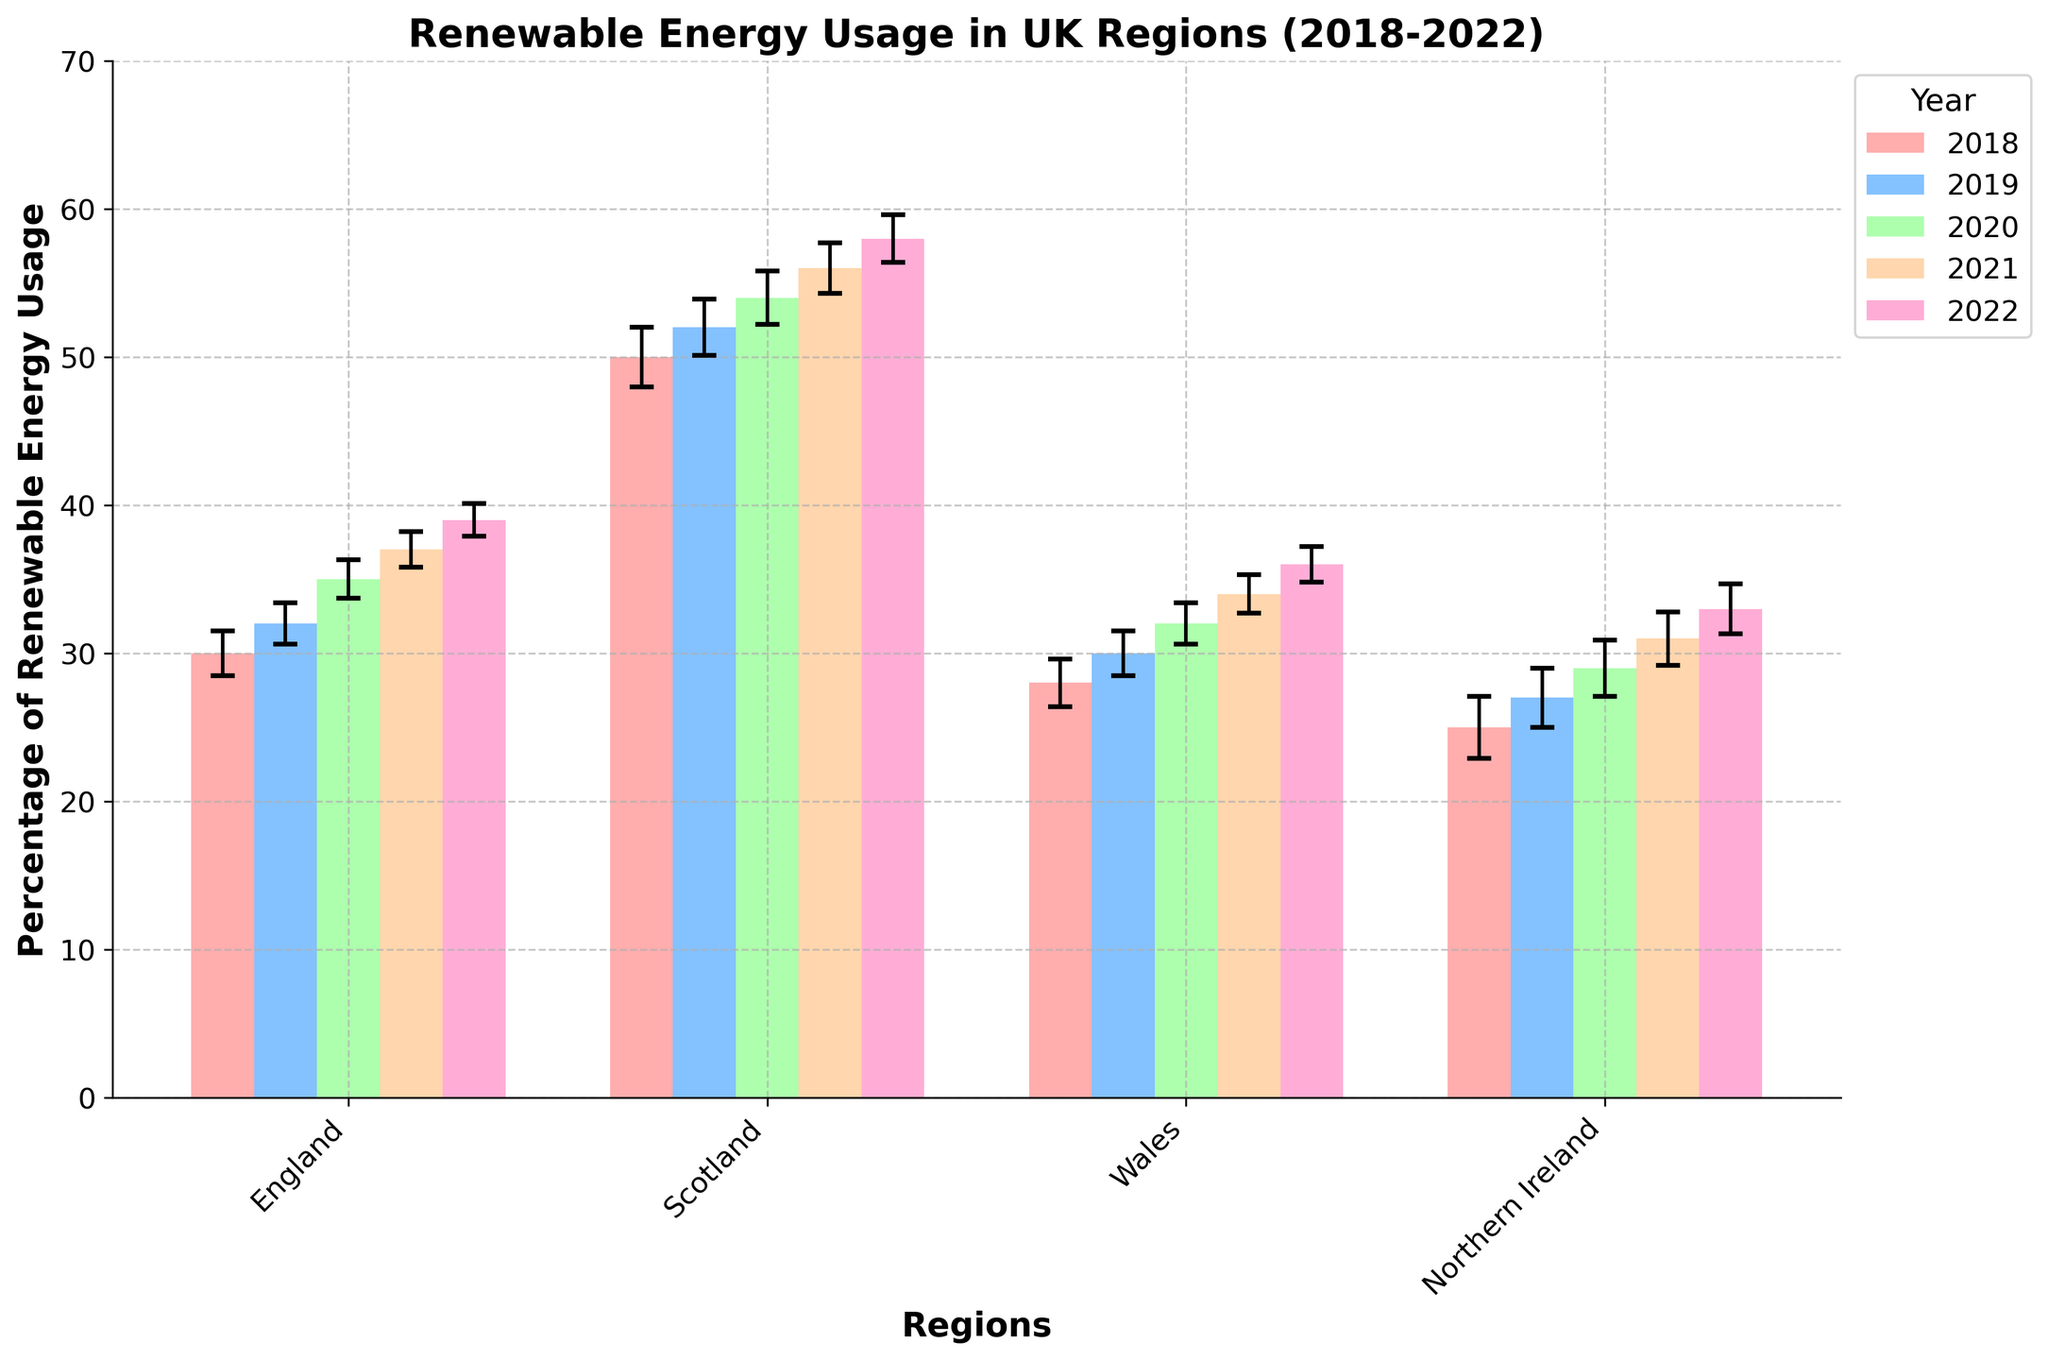what's the title of the chart? The title is generally found at the top of the chart, and it helps to understand the main focus of the data presented.
Answer: Renewable Energy Usage in UK Regions (2018-2022) how many regions are compared on the x-axis? The x-axis represents the different regions being compared. By counting the labels, we can determine the number of regions.
Answer: 4 which region used the highest percentage of renewable energy in 2022? By looking at the height of the bars for 2022 (the rightmost bars for each group) and comparing the percentages, we can identify the region with the highest value.
Answer: Scotland what is the range of the error bars for renewable energy usage in England in 2020? The error bars indicate the uncertainty or variability in the data. In 2020, we observe the error bar for England's bar to determine its range.
Answer: 33.7 to 36.3 which year showed the greatest increase in renewable energy usage for Northern Ireland? By observing the differences in bar heights for Northern Ireland across the years, we can determine the year with the greatest increase.
Answer: 2021 compare the renewable energy usage in Wales between 2018 and 2021. which year had a higher percentage? By comparing the heights of the bars for Wales in 2018 and 2021, we can identify which year had a higher percentage.
Answer: 2021 which region had a lower percentage of renewable energy usage than Wales in 2019? By comparing the height of the bar for Wales in 2019 to the bars of other regions in the same year, we can identify any regions with lower percentages.
Answer: Northern Ireland which year had the smallest error bars for renewable energy usage in Scotland? By comparing the lengths of the error bars for Scotland across all years, we can identify the year with the smallest error bars.
Answer: 2022 what's the mean percentage of renewable energy usage in England over the given period? To calculate the mean, sum the percentages for England over the years and divide by the number of years: (30+32+35+37+39)/5.
Answer: 34.6 what is the trend of renewable energy usage in Wales from 2018 to 2022? Observing the heights of the bars for Wales in sequence from 2018 to 2022 shows an increasing pattern, indicating a rising trend.
Answer: Increasing 